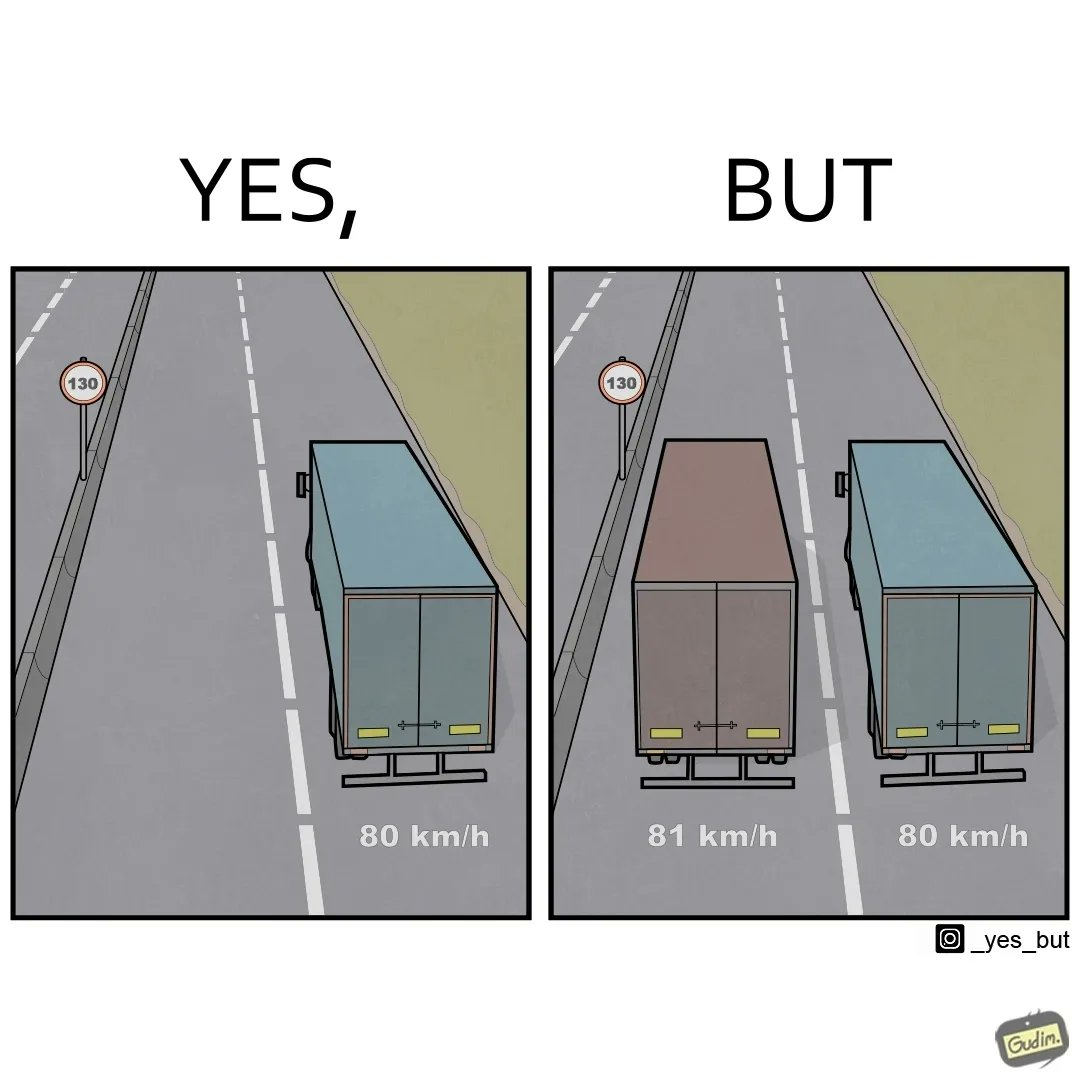Describe what you see in this image. The images are funny since even though the speed limit in the zone is 130km/h, a truck travelling at 81 km/h decides to overtake another travelling 80km/h. The faster truck is barely faster and takes a long time to overtake causing other faster road users to get annoyed. 